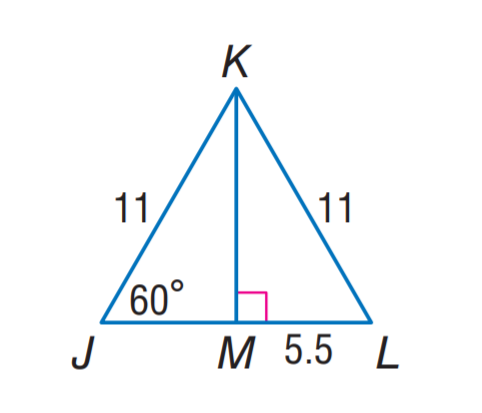Question: Find J M.
Choices:
A. 4.5
B. 5.5
C. 6
D. 11
Answer with the letter. Answer: B Question: Find m \angle J K L.
Choices:
A. 30
B. 50
C. 60
D. 80
Answer with the letter. Answer: C 